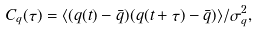<formula> <loc_0><loc_0><loc_500><loc_500>C _ { q } ( \tau ) = \langle ( q ( t ) - { \bar { q } } ) ( q ( t + \tau ) - { \bar { q } } ) \rangle / \sigma _ { q } ^ { 2 } ,</formula> 